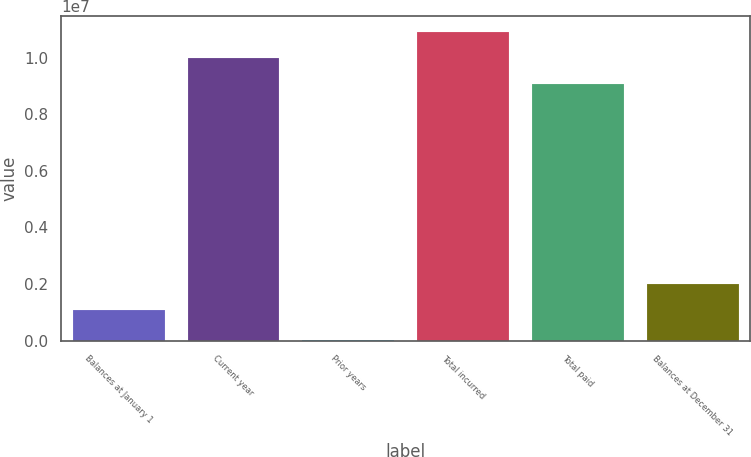Convert chart to OTSL. <chart><loc_0><loc_0><loc_500><loc_500><bar_chart><fcel>Balances at January 1<fcel>Current year<fcel>Prior years<fcel>Total incurred<fcel>Total paid<fcel>Balances at December 31<nl><fcel>1.08639e+06<fcel>9.99504e+06<fcel>12281<fcel>1.09076e+07<fcel>9.08245e+06<fcel>1.99898e+06<nl></chart> 